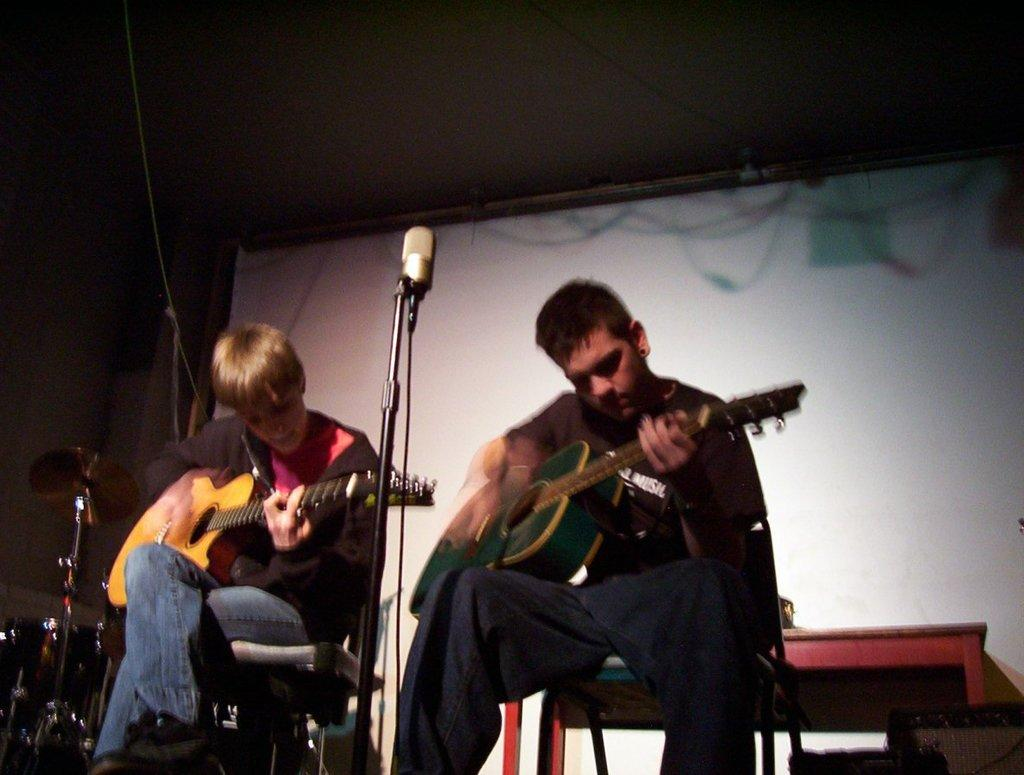How many people are in the image? There are two persons sitting in the image. What are the persons holding in the image? The persons are holding guitars. What object is present for amplifying sound in the image? There is a microphone with a stand in the image. What can be seen in the background of the image? There is a banner visible in the background. How many musical instruments can be seen in the image? There is at least one musical instrument in the image, which are the guitars held by the persons. What type of jam is being prepared by the persons in the image? There is no jam preparation visible in the image; the persons are holding guitars and there is a microphone with a stand, suggesting a musical setting. 